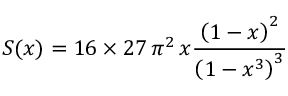Convert formula to latex. <formula><loc_0><loc_0><loc_500><loc_500>S ( x ) = 1 6 \times 2 7 \, \pi ^ { 2 } \, x \frac { \left ( 1 - x \right ) ^ { 2 } } { \left ( 1 - x ^ { 3 } \right ) ^ { 3 } }</formula> 